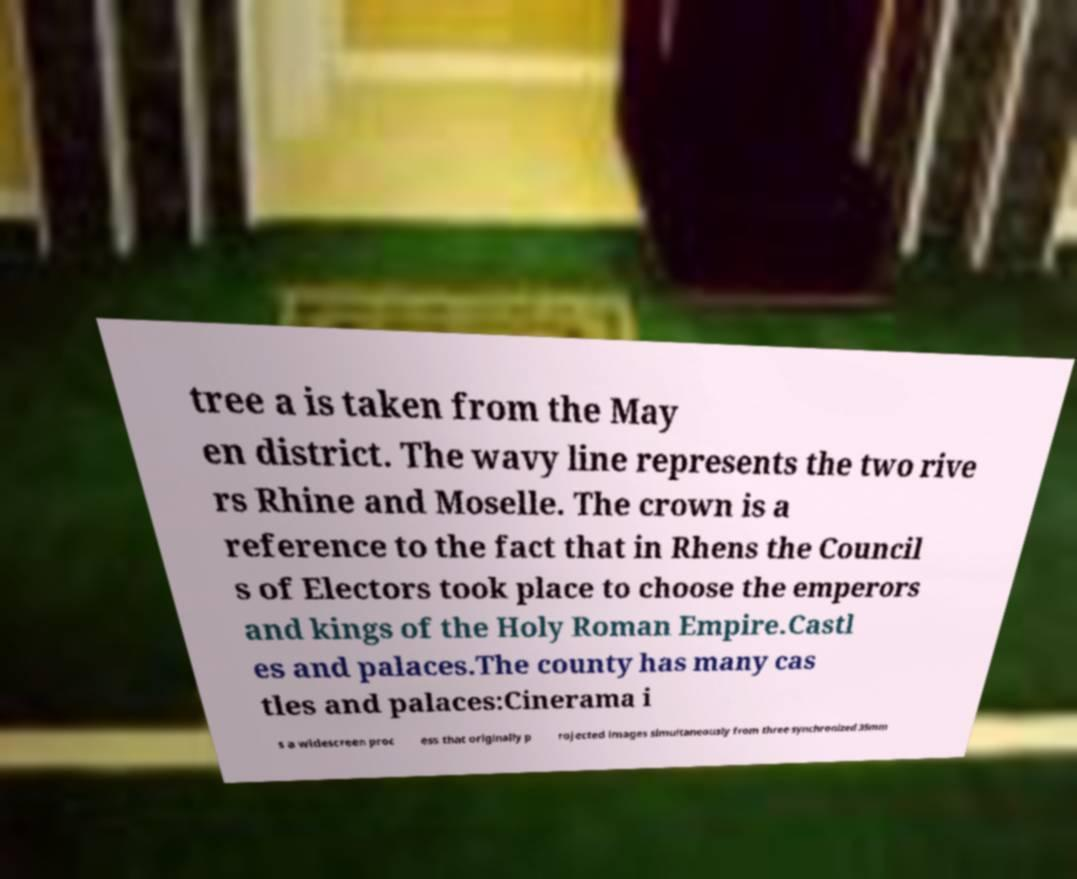Could you extract and type out the text from this image? tree a is taken from the May en district. The wavy line represents the two rive rs Rhine and Moselle. The crown is a reference to the fact that in Rhens the Council s of Electors took place to choose the emperors and kings of the Holy Roman Empire.Castl es and palaces.The county has many cas tles and palaces:Cinerama i s a widescreen proc ess that originally p rojected images simultaneously from three synchronized 35mm 